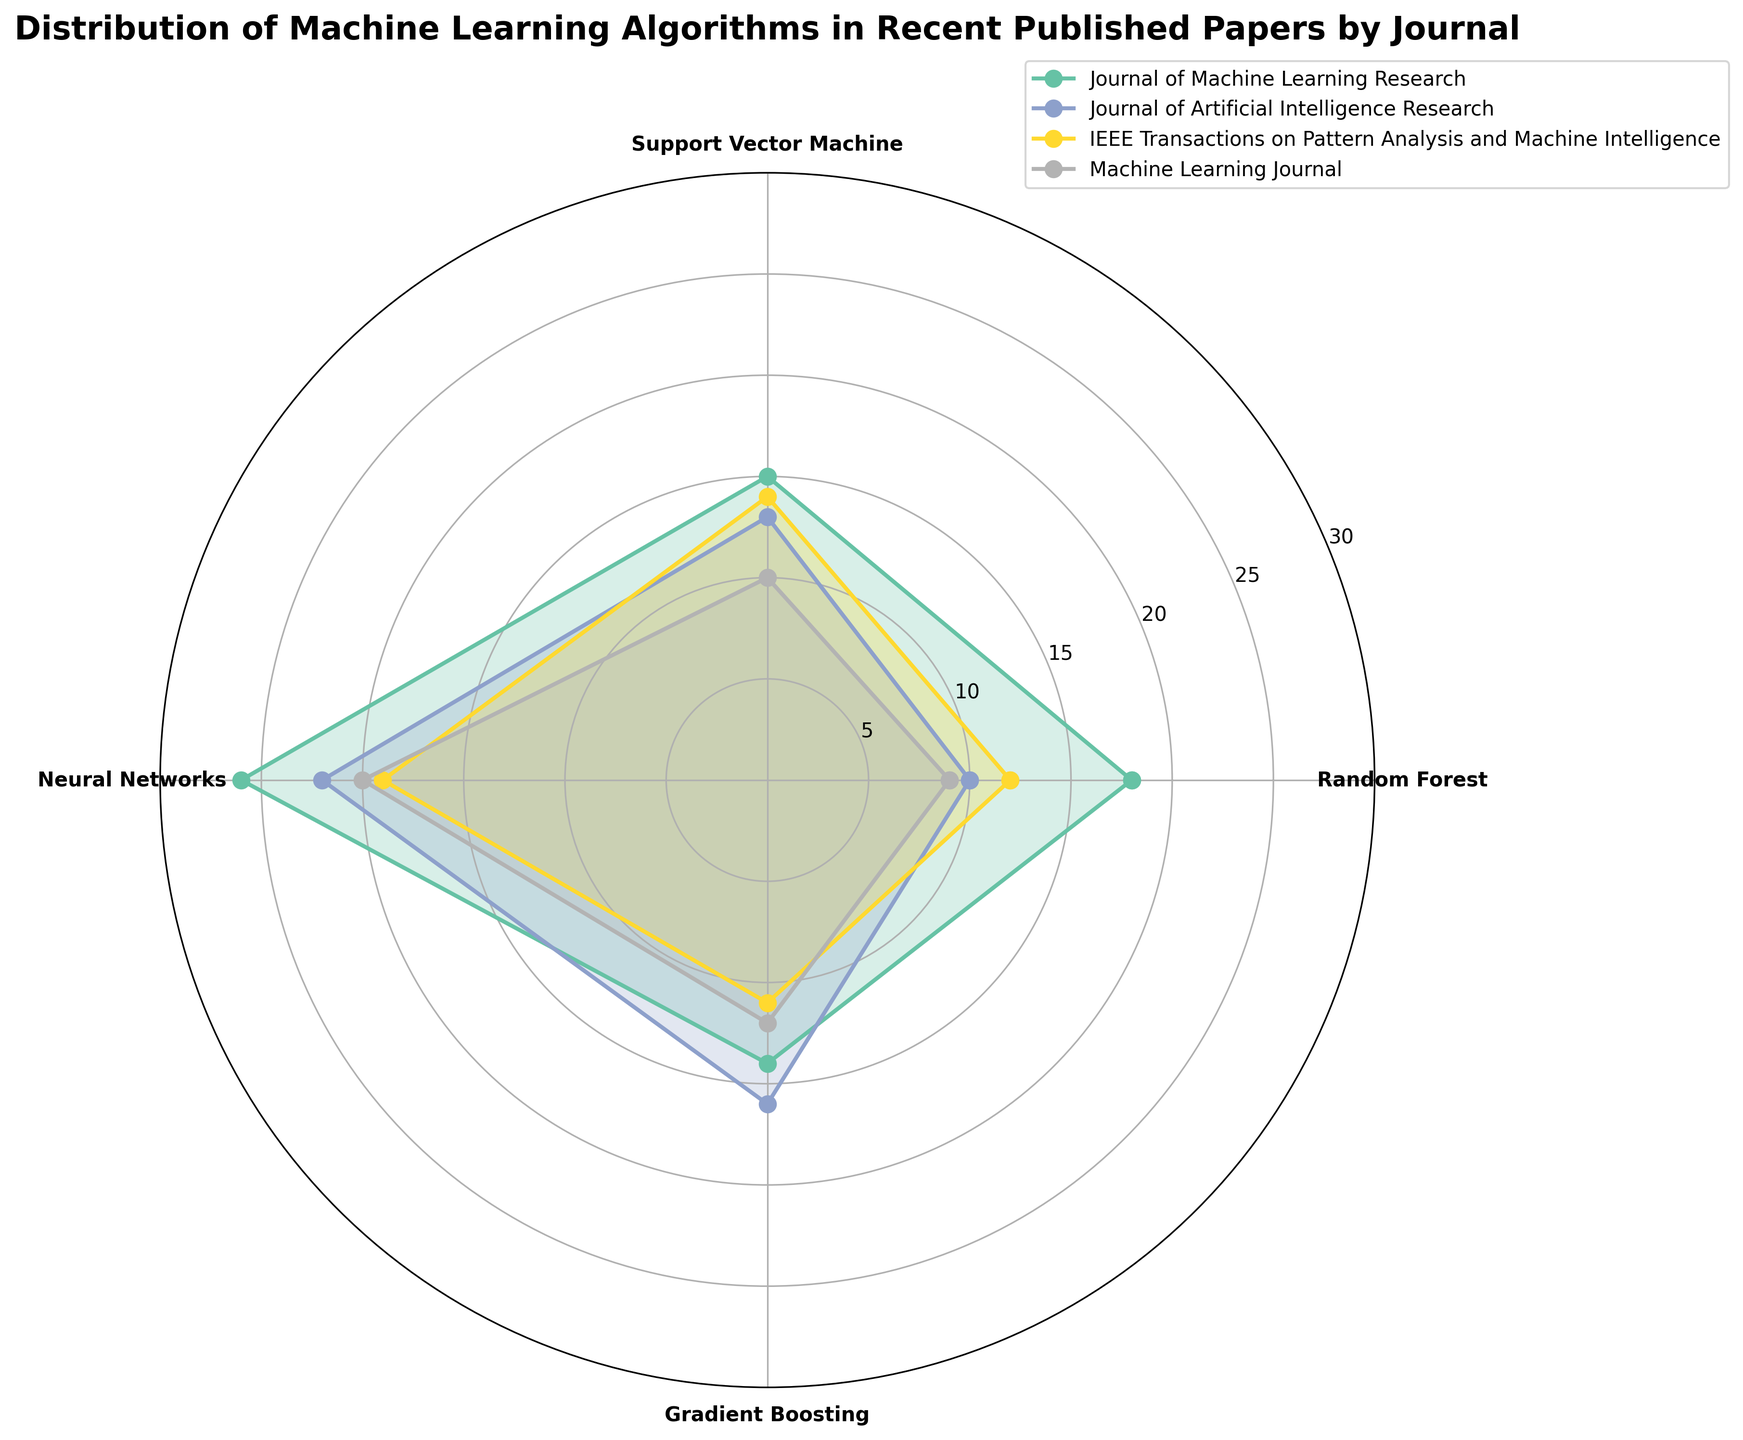What's the title of the plot? The title is located at the top of the figure and it describes the main topic of the plot. It reads "Distribution of Machine Learning Algorithms in Recent Published Papers by Journal".
Answer: Distribution of Machine Learning Algorithms in Recent Published Papers by Journal Which journal uses Neural Networks the most? To find the answer, look at the section corresponding to 'Neural Networks' and compare the lengths of the plotted lines from the center to the journal names. The Journal of Machine Learning Research has the farthest line for Neural Networks.
Answer: Journal of Machine Learning Research Which algorithm appears the least frequently in the Machine Learning Journal? Examine the sections labeled for the Machine Learning Journal and compare the four data points (one for each algorithm). The smallest value appears for Random Forest.
Answer: Random Forest How many journals are depicted in the rose chart? Count the distinct colored data series (polygons) in the rose chart. There are four different polygons, each representing a unique journal.
Answer: 4 Compare the number of times Support Vector Machine and Gradient Boosting are used in the IEEE Transactions on Pattern Analysis and Machine Intelligence. Which one is used more? Locate the lines for 'Support Vector Machine' and 'Gradient Boosting' specific to the IEEE Transactions on Pattern Analysis and Machine Intelligence. The line for Support Vector Machine is longer, indicating it's used more frequently.
Answer: Support Vector Machine On average, how many times is Random Forest used per journal? Sum the counts of Random Forest across all journals (18 + 10 + 12 + 9 = 49) and divide by the number of journals (4). The average is 49/4 = 12.25.
Answer: 12.25 How many types of machine learning algorithms are represented in the chart? This can be determined by looking at the axis labels around the chart, representing different machine learning algorithms. There are four labels, indicating four types of algorithms.
Answer: 4 Is Gradient Boosting used more in the Machine Learning Journal or the Journal of Artificial Intelligence Research? Compare the lengths of the lines for 'Gradient Boosting' in both the Machine Learning Journal and the Journal of Artificial Intelligence Research. The Journal of Artificial Intelligence Research has a longer line, indicating more usage.
Answer: Journal of Artificial Intelligence Research Which journal shows the most diverse use of machine learning algorithms? Assess the variation in lengths of the plotted lines for each journal. The Journal of Machine Learning Research shows relatively high counts across all algorithms, indicating diverse use.
Answer: Journal of Machine Learning Research 